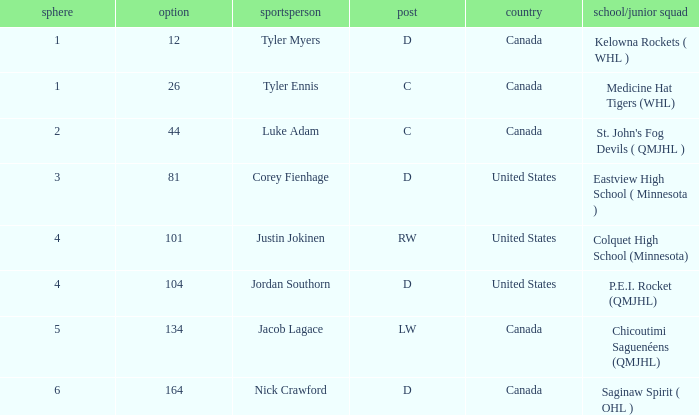What is the college/junior team of player tyler myers, who has a pick less than 44? Kelowna Rockets ( WHL ). 